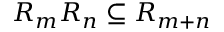Convert formula to latex. <formula><loc_0><loc_0><loc_500><loc_500>R _ { m } R _ { n } \subseteq R _ { m + n }</formula> 